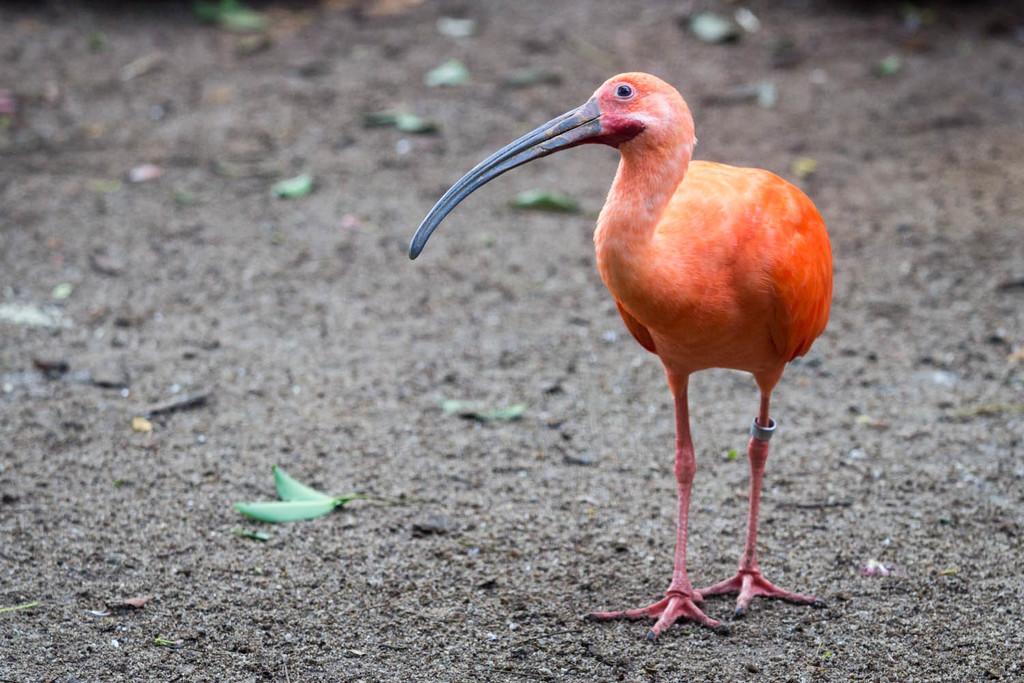In one or two sentences, can you explain what this image depicts? In this picture I can see a bird and leaves on the ground. 